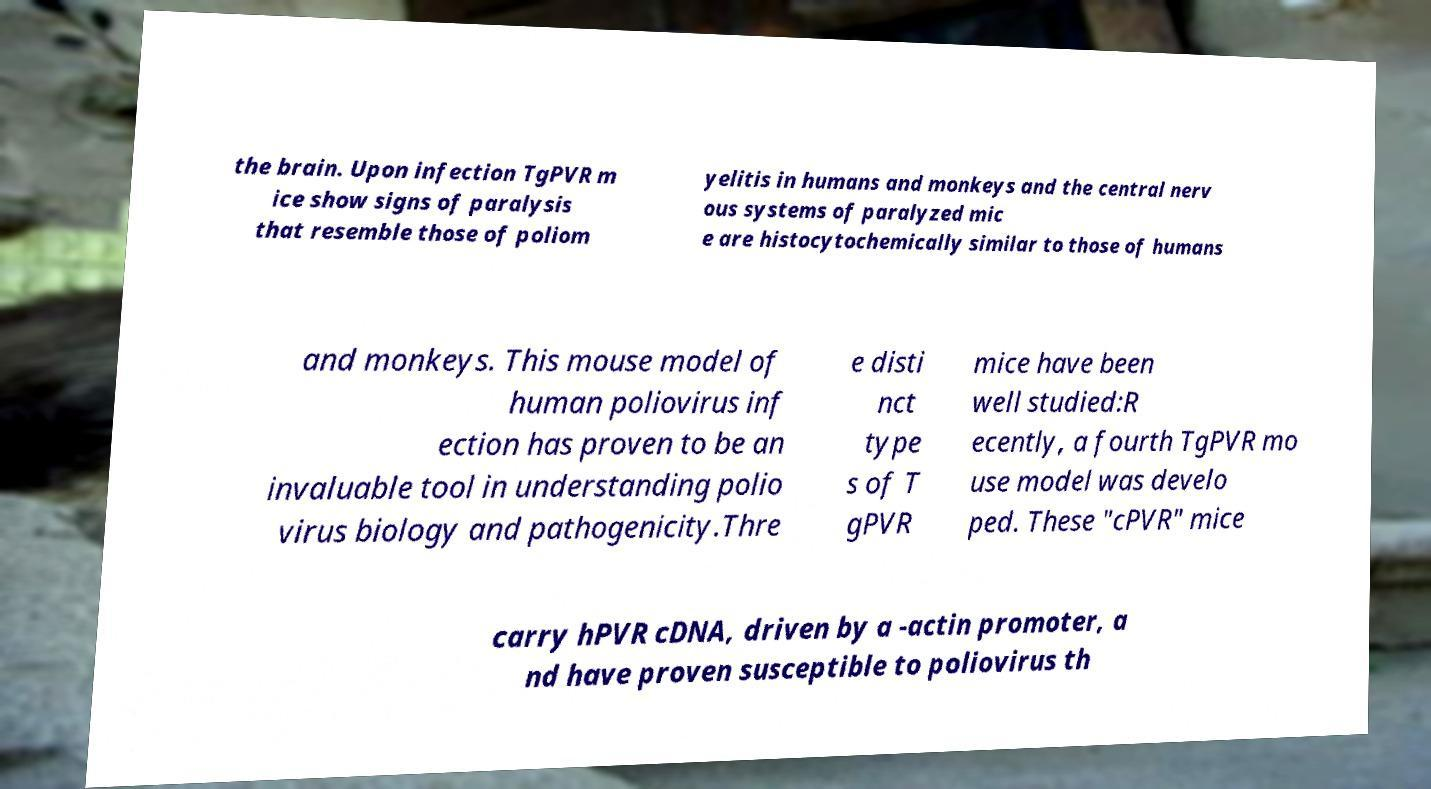I need the written content from this picture converted into text. Can you do that? the brain. Upon infection TgPVR m ice show signs of paralysis that resemble those of poliom yelitis in humans and monkeys and the central nerv ous systems of paralyzed mic e are histocytochemically similar to those of humans and monkeys. This mouse model of human poliovirus inf ection has proven to be an invaluable tool in understanding polio virus biology and pathogenicity.Thre e disti nct type s of T gPVR mice have been well studied:R ecently, a fourth TgPVR mo use model was develo ped. These "cPVR" mice carry hPVR cDNA, driven by a -actin promoter, a nd have proven susceptible to poliovirus th 